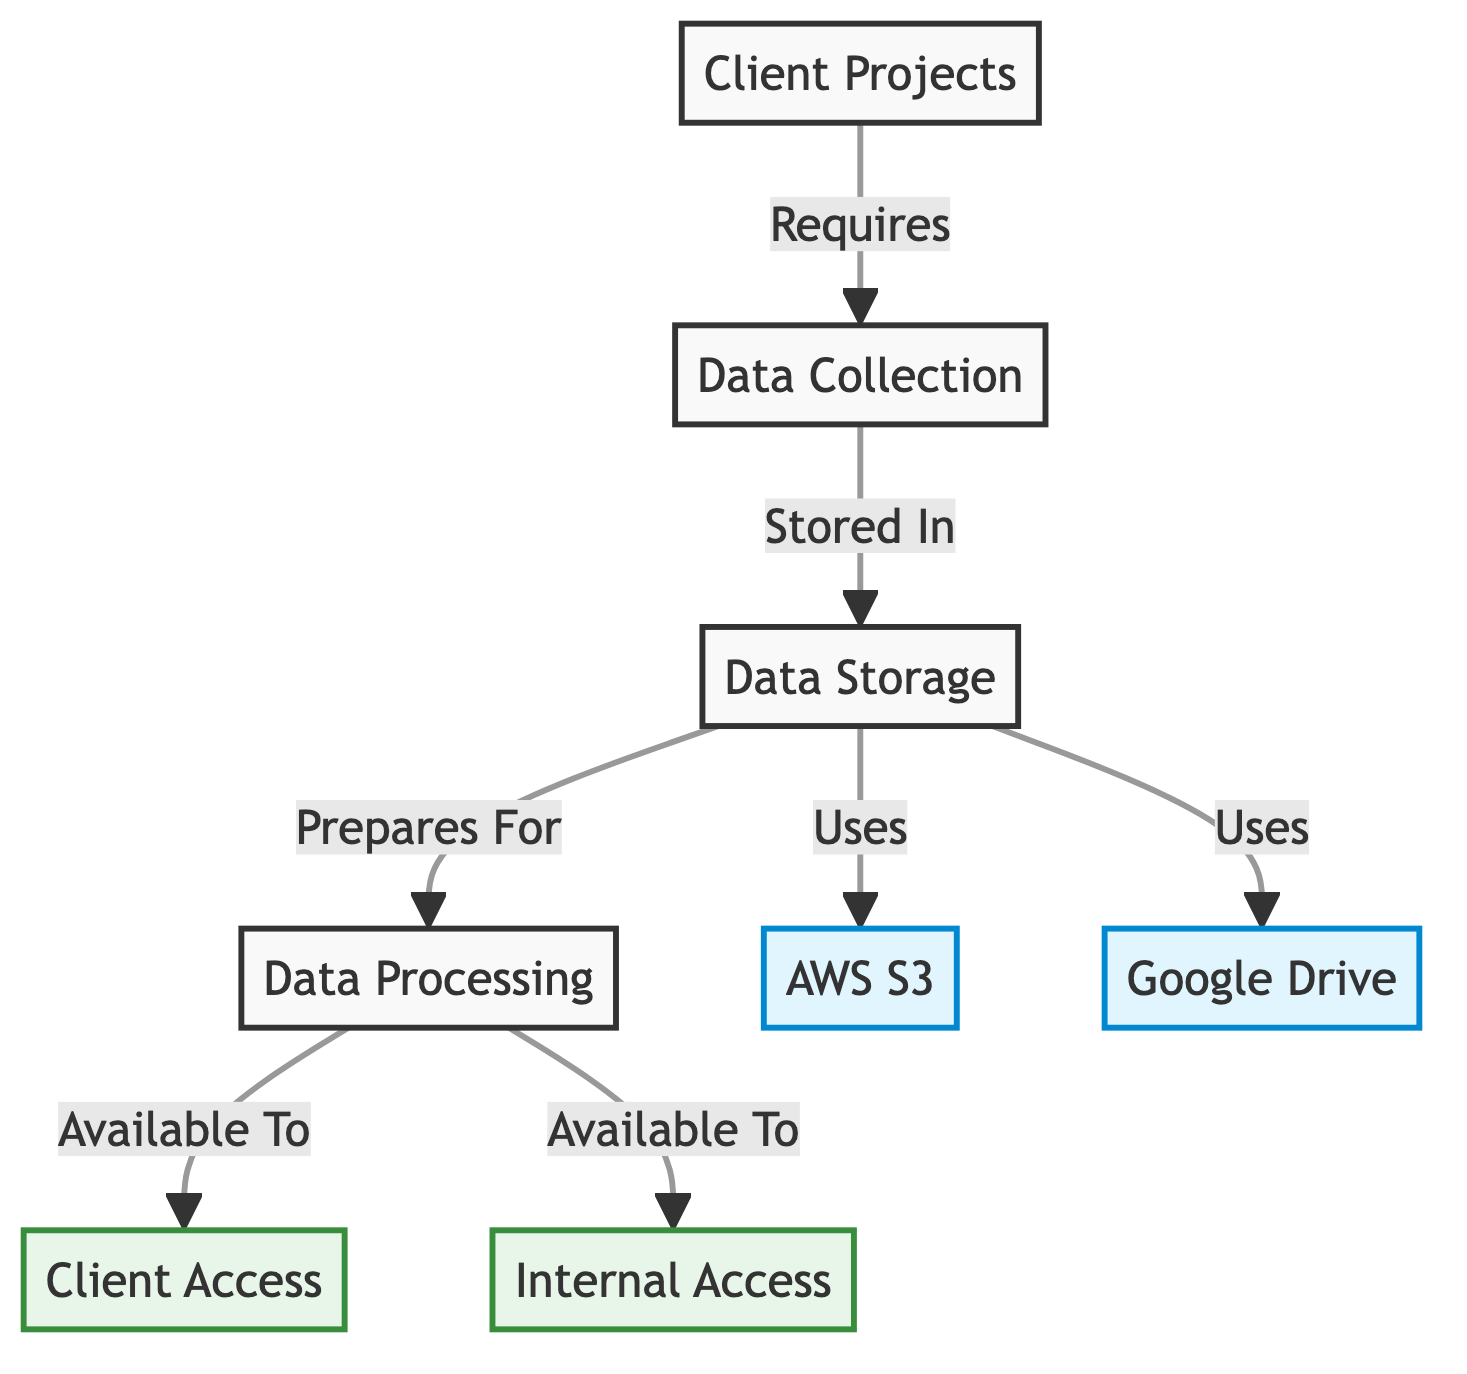What is the first step in the data flow? The diagram indicates that the first step is "Client Projects," which is the entry point in the flow.
Answer: Client Projects How many storage solutions are used in the diagram? The diagram shows two storage solutions: "AWS S3" and "Google Drive." Therefore, the number is two.
Answer: 2 What type of access is "Client Access"? "Client Access" is classified as an access node, and the diagram is color-coded to indicate this type distinguishes it.
Answer: access Which node prepares for data processing? The diagram shows that "Data Storage" prepares for "Data Processing," indicating the step that comes before data processing.
Answer: Data Storage Which storage is used to store data? The diagram specifies that data is stored in both "AWS S3" and "Google Drive," highlighting the storage solutions utilized.
Answer: AWS S3, Google Drive How many nodes are available for internal and client access combined? The diagram shows two access nodes: "Client Access" and "Internal Access," so summing these gives a total of two nodes available for access.
Answer: 2 What indicates the relationship between "Data Collection" and "Data Storage"? The relationship is indicated by the arrow going from "Data Collection" to "Data Storage," which denotes that data collected is subsequently stored.
Answer: Stored In Which phase comes after data storage? The diagram specifies that after "Data Storage," the next phase is "Data Processing," creating a sequential flow of operations.
Answer: Data Processing What is the color of the "Data Processing" node? The color of the "Data Processing" node is a shade of purple, as indicated in the diagram's color-coding legend.
Answer: purple 